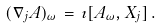Convert formula to latex. <formula><loc_0><loc_0><loc_500><loc_500>( \nabla _ { j } A ) _ { \omega } \, = \, \imath [ A _ { \omega } , X _ { j } ] \, .</formula> 